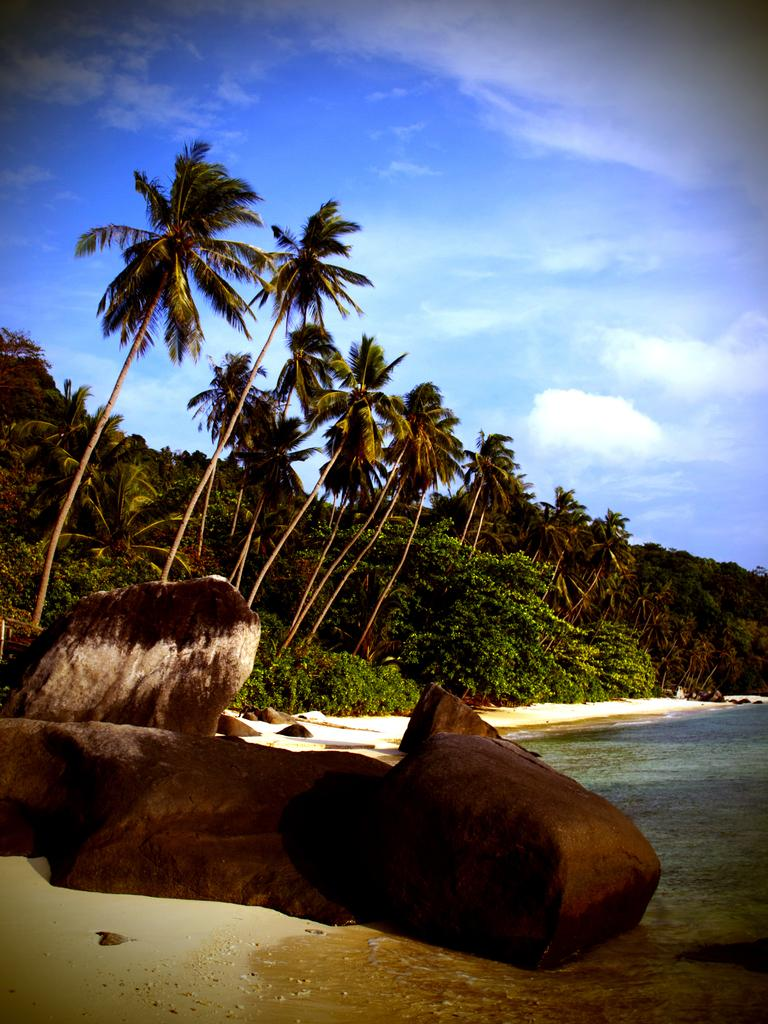What type of natural elements can be seen in the image? There are trees and rocks visible in the image. What can be seen on the right side of the image? There is water visible on the right side of the image. What is visible in the background of the image? The sky is visible in the background of the image. Where is the throne located in the image? There is no throne present in the image. Can you see any tomatoes growing on the trees in the image? Tomatoes do not grow on trees; they grow on vines. Additionally, there are no tomatoes visible in the image. 